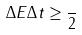<formula> <loc_0><loc_0><loc_500><loc_500>\Delta E \Delta t \geq \frac { } { 2 }</formula> 